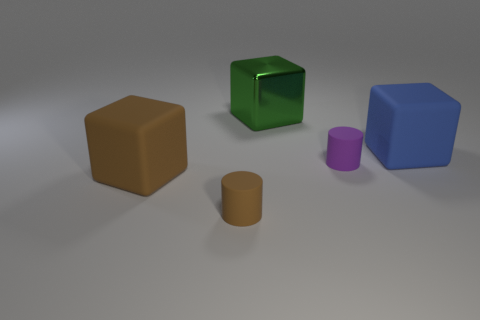What number of matte things are tiny brown cylinders or blocks?
Provide a succinct answer. 3. There is another thing that is the same size as the purple rubber thing; what is it made of?
Make the answer very short. Rubber. How many other things are there of the same material as the large blue object?
Keep it short and to the point. 3. Is the number of small brown objects that are in front of the tiny brown thing less than the number of large green blocks?
Make the answer very short. Yes. Do the big green object and the big blue matte thing have the same shape?
Provide a succinct answer. Yes. What size is the cylinder behind the matte cylinder that is left of the rubber cylinder that is behind the large brown rubber thing?
Ensure brevity in your answer.  Small. What is the material of the other large brown object that is the same shape as the big metal thing?
Provide a short and direct response. Rubber. There is a rubber cylinder that is to the left of the small rubber thing behind the brown rubber cube; what size is it?
Make the answer very short. Small. What is the color of the shiny cube?
Offer a terse response. Green. What number of large blue objects are to the left of the large cube in front of the large blue rubber thing?
Your answer should be very brief. 0. 